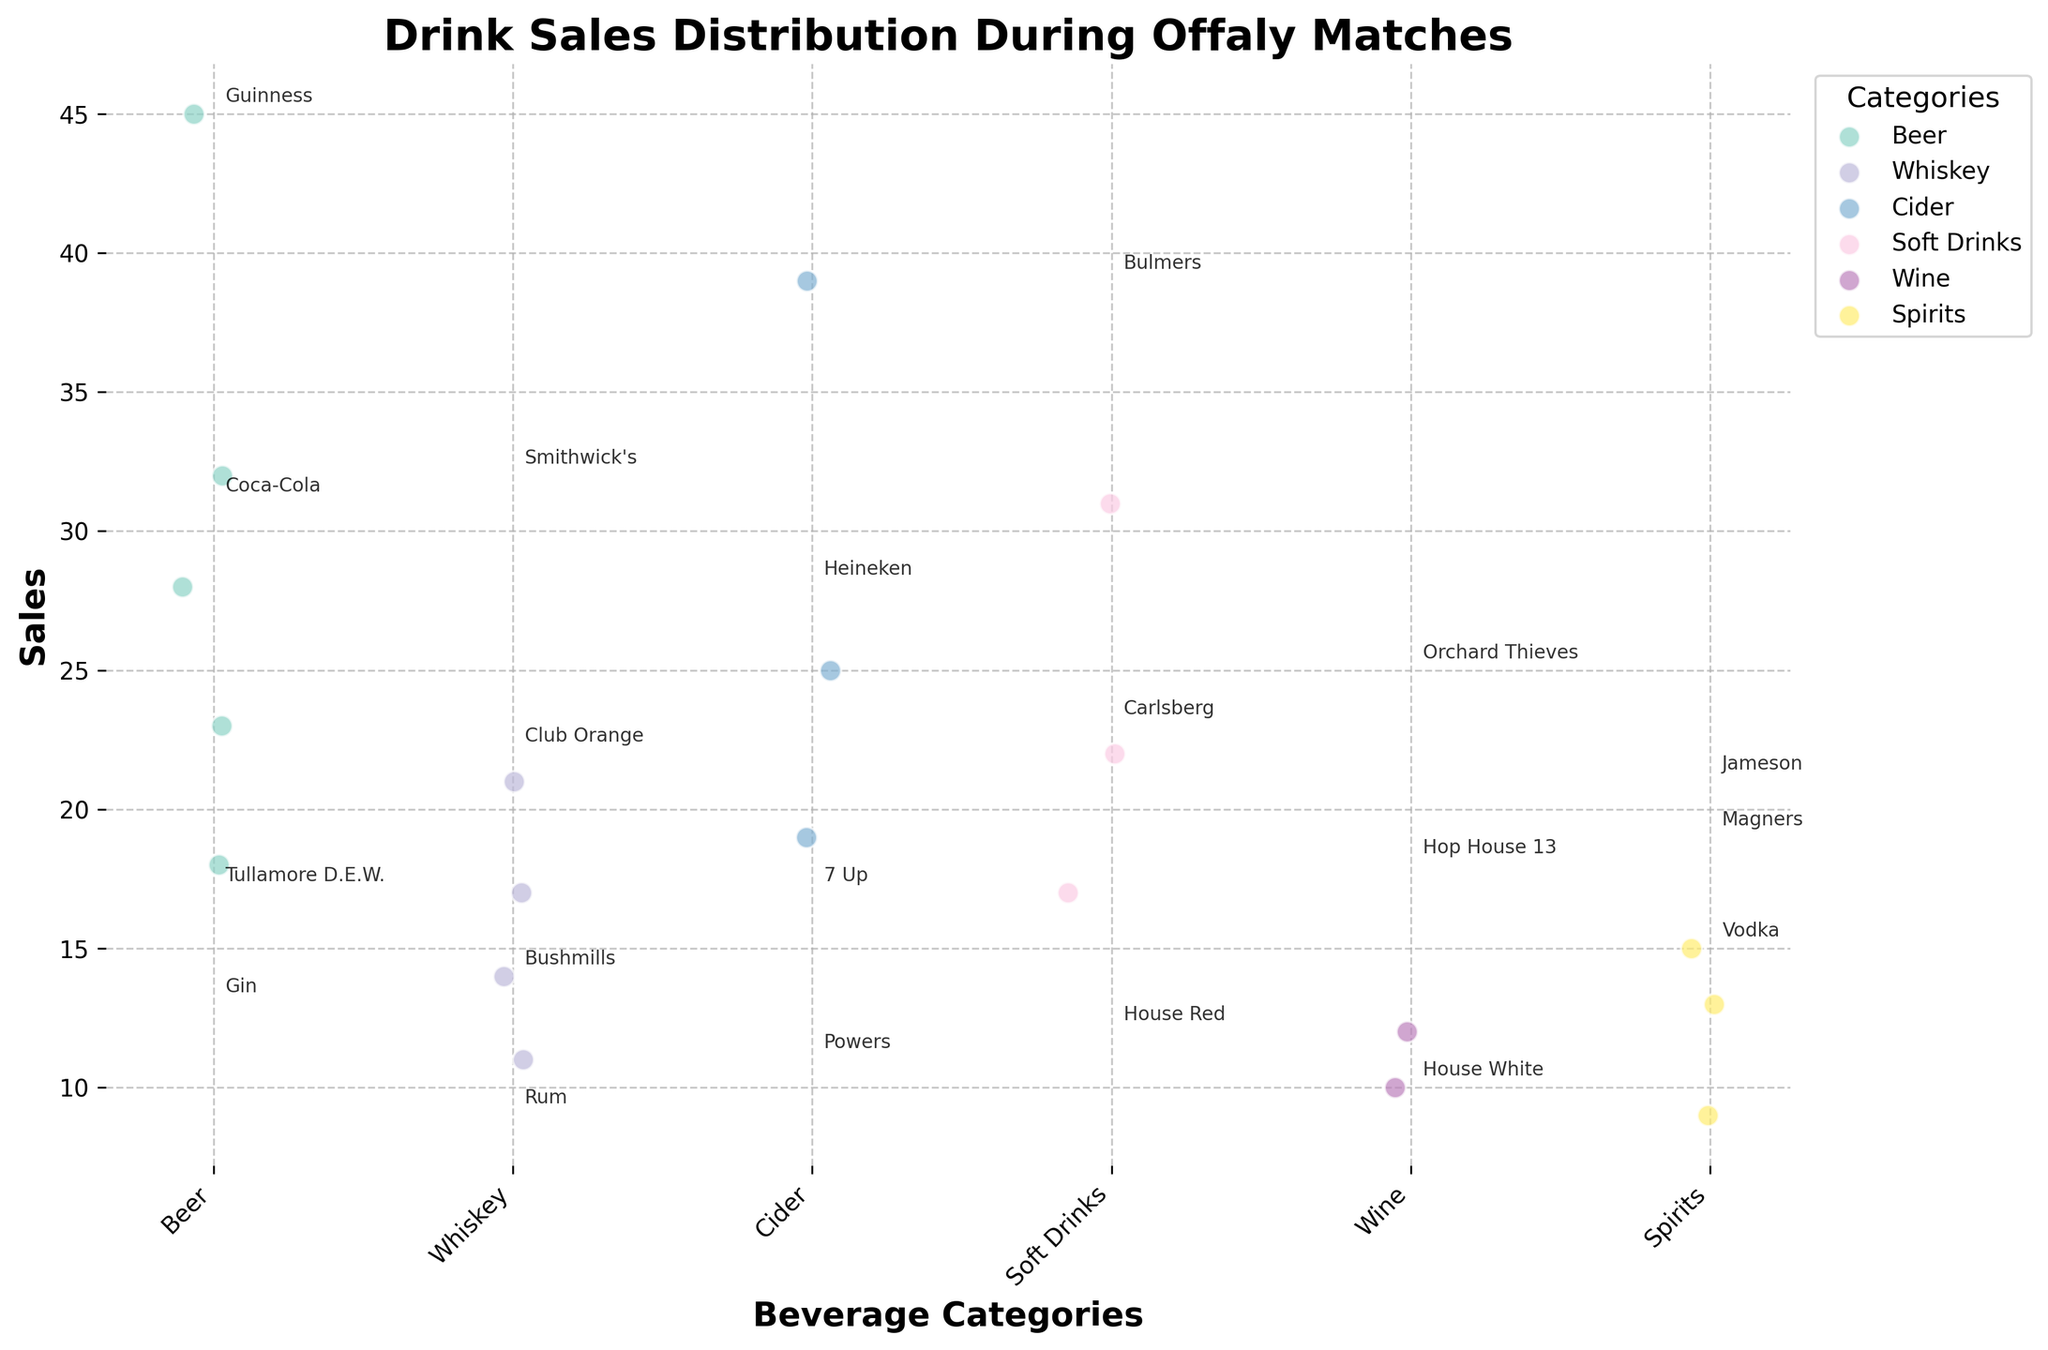What is the title of the plot? The title of the plot is located at the top center and usually describes the main topic of the plot.
Answer: Drink Sales Distribution During Offaly Matches How many beverage categories are there? To find the number of beverage categories, look at the x-axis labels.
Answer: 6 Which category has the highest sales value? Observe the spread of data points for each category along the y-axis to determine which has the highest value.
Answer: Beer What is the sales value of Guinness? Look for the annotated data point labeled 'Guinness' and note its value along the y-axis.
Answer: 45 Which soft drink has the highest sales? Identify the data points within the Soft Drinks category and compare their sales values.
Answer: Coca-Cola What is the difference in sales between Guinness and Carlsberg? Find the sales values of both drinks (45 for Guinness, 23 for Carlsberg) and calculate the difference.
Answer: 22 How many drinks are in the Whiskey category? Count the number of annotated data points within the Whiskey category.
Answer: 4 Which has higher sales, Jameson or Smithwick's? Compare the y-axis values of the data points labeled 'Jameson' and 'Smithwick's'.
Answer: Smithwick's What is the average sales value for the Cider category? Add the sales values of Bulmers, Orchard Thieves, and Magners (39 + 25 + 19) and divide by 3.
Answer: 27.67 Which category has the lowest maximum sales value? Find the highest sales value for each category and identify the category with the lowest of these values.
Answer: Spirits 